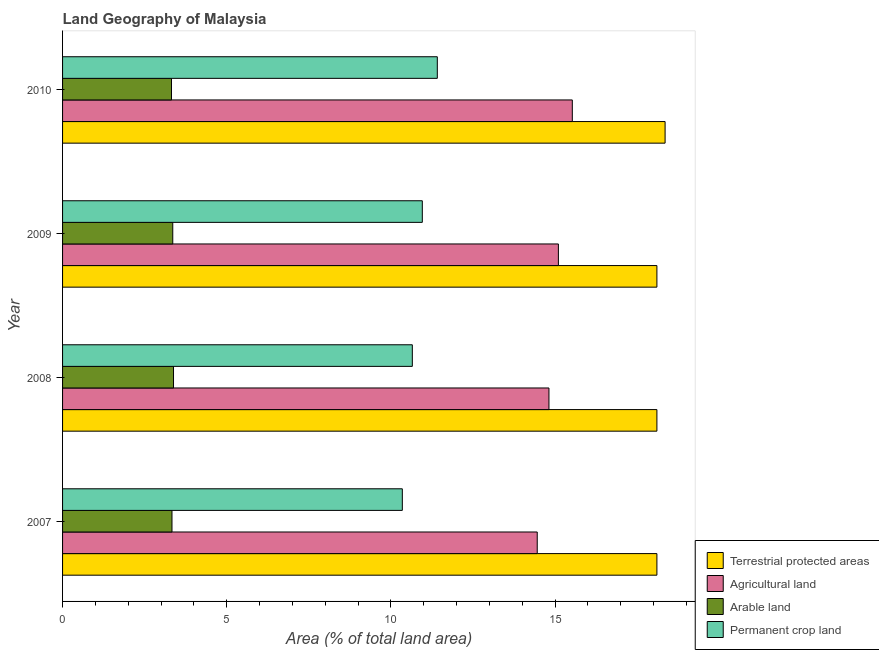Are the number of bars per tick equal to the number of legend labels?
Your answer should be compact. Yes. How many bars are there on the 2nd tick from the top?
Provide a short and direct response. 4. What is the label of the 4th group of bars from the top?
Provide a succinct answer. 2007. In how many cases, is the number of bars for a given year not equal to the number of legend labels?
Offer a terse response. 0. What is the percentage of area under permanent crop land in 2008?
Give a very brief answer. 10.65. Across all years, what is the maximum percentage of area under permanent crop land?
Offer a terse response. 11.41. Across all years, what is the minimum percentage of land under terrestrial protection?
Provide a short and direct response. 18.1. In which year was the percentage of area under arable land minimum?
Keep it short and to the point. 2010. What is the total percentage of area under permanent crop land in the graph?
Your answer should be compact. 43.37. What is the difference between the percentage of area under arable land in 2007 and that in 2008?
Offer a very short reply. -0.05. What is the difference between the percentage of area under agricultural land in 2010 and the percentage of area under permanent crop land in 2008?
Keep it short and to the point. 4.87. What is the average percentage of area under arable land per year?
Provide a short and direct response. 3.35. In the year 2008, what is the difference between the percentage of area under agricultural land and percentage of land under terrestrial protection?
Your answer should be very brief. -3.29. What is the ratio of the percentage of area under permanent crop land in 2008 to that in 2010?
Make the answer very short. 0.93. What is the difference between the highest and the second highest percentage of area under agricultural land?
Your response must be concise. 0.42. What is the difference between the highest and the lowest percentage of area under permanent crop land?
Provide a short and direct response. 1.07. In how many years, is the percentage of area under arable land greater than the average percentage of area under arable land taken over all years?
Your response must be concise. 2. Is the sum of the percentage of area under permanent crop land in 2008 and 2009 greater than the maximum percentage of area under agricultural land across all years?
Your answer should be very brief. Yes. What does the 4th bar from the top in 2009 represents?
Make the answer very short. Terrestrial protected areas. What does the 2nd bar from the bottom in 2007 represents?
Keep it short and to the point. Agricultural land. Are all the bars in the graph horizontal?
Provide a short and direct response. Yes. Does the graph contain any zero values?
Keep it short and to the point. No. Where does the legend appear in the graph?
Give a very brief answer. Bottom right. How are the legend labels stacked?
Your answer should be very brief. Vertical. What is the title of the graph?
Offer a terse response. Land Geography of Malaysia. Does "Korea" appear as one of the legend labels in the graph?
Your answer should be very brief. No. What is the label or title of the X-axis?
Provide a succinct answer. Area (% of total land area). What is the label or title of the Y-axis?
Your answer should be compact. Year. What is the Area (% of total land area) of Terrestrial protected areas in 2007?
Your answer should be compact. 18.1. What is the Area (% of total land area) in Agricultural land in 2007?
Make the answer very short. 14.46. What is the Area (% of total land area) in Arable land in 2007?
Provide a succinct answer. 3.33. What is the Area (% of total land area) in Permanent crop land in 2007?
Provide a succinct answer. 10.35. What is the Area (% of total land area) of Terrestrial protected areas in 2008?
Your response must be concise. 18.1. What is the Area (% of total land area) in Agricultural land in 2008?
Offer a terse response. 14.81. What is the Area (% of total land area) in Arable land in 2008?
Provide a succinct answer. 3.38. What is the Area (% of total land area) of Permanent crop land in 2008?
Your response must be concise. 10.65. What is the Area (% of total land area) in Terrestrial protected areas in 2009?
Your answer should be compact. 18.1. What is the Area (% of total land area) in Agricultural land in 2009?
Your answer should be compact. 15.1. What is the Area (% of total land area) of Arable land in 2009?
Make the answer very short. 3.36. What is the Area (% of total land area) in Permanent crop land in 2009?
Make the answer very short. 10.96. What is the Area (% of total land area) in Terrestrial protected areas in 2010?
Provide a succinct answer. 18.35. What is the Area (% of total land area) of Agricultural land in 2010?
Provide a short and direct response. 15.53. What is the Area (% of total land area) in Arable land in 2010?
Ensure brevity in your answer.  3.32. What is the Area (% of total land area) in Permanent crop land in 2010?
Offer a very short reply. 11.41. Across all years, what is the maximum Area (% of total land area) in Terrestrial protected areas?
Keep it short and to the point. 18.35. Across all years, what is the maximum Area (% of total land area) in Agricultural land?
Offer a very short reply. 15.53. Across all years, what is the maximum Area (% of total land area) in Arable land?
Your answer should be very brief. 3.38. Across all years, what is the maximum Area (% of total land area) in Permanent crop land?
Your response must be concise. 11.41. Across all years, what is the minimum Area (% of total land area) in Terrestrial protected areas?
Ensure brevity in your answer.  18.1. Across all years, what is the minimum Area (% of total land area) in Agricultural land?
Keep it short and to the point. 14.46. Across all years, what is the minimum Area (% of total land area) in Arable land?
Give a very brief answer. 3.32. Across all years, what is the minimum Area (% of total land area) in Permanent crop land?
Your answer should be compact. 10.35. What is the total Area (% of total land area) in Terrestrial protected areas in the graph?
Provide a succinct answer. 72.66. What is the total Area (% of total land area) in Agricultural land in the graph?
Ensure brevity in your answer.  59.9. What is the total Area (% of total land area) in Arable land in the graph?
Offer a terse response. 13.39. What is the total Area (% of total land area) of Permanent crop land in the graph?
Give a very brief answer. 43.37. What is the difference between the Area (% of total land area) in Terrestrial protected areas in 2007 and that in 2008?
Provide a short and direct response. 0. What is the difference between the Area (% of total land area) in Agricultural land in 2007 and that in 2008?
Ensure brevity in your answer.  -0.36. What is the difference between the Area (% of total land area) of Arable land in 2007 and that in 2008?
Make the answer very short. -0.05. What is the difference between the Area (% of total land area) in Permanent crop land in 2007 and that in 2008?
Provide a short and direct response. -0.3. What is the difference between the Area (% of total land area) of Terrestrial protected areas in 2007 and that in 2009?
Your answer should be compact. 0. What is the difference between the Area (% of total land area) of Agricultural land in 2007 and that in 2009?
Your answer should be compact. -0.64. What is the difference between the Area (% of total land area) in Arable land in 2007 and that in 2009?
Your response must be concise. -0.02. What is the difference between the Area (% of total land area) of Permanent crop land in 2007 and that in 2009?
Keep it short and to the point. -0.61. What is the difference between the Area (% of total land area) of Terrestrial protected areas in 2007 and that in 2010?
Keep it short and to the point. -0.25. What is the difference between the Area (% of total land area) of Agricultural land in 2007 and that in 2010?
Offer a terse response. -1.07. What is the difference between the Area (% of total land area) in Arable land in 2007 and that in 2010?
Offer a very short reply. 0.02. What is the difference between the Area (% of total land area) in Permanent crop land in 2007 and that in 2010?
Your answer should be very brief. -1.07. What is the difference between the Area (% of total land area) of Agricultural land in 2008 and that in 2009?
Offer a very short reply. -0.29. What is the difference between the Area (% of total land area) of Arable land in 2008 and that in 2009?
Make the answer very short. 0.02. What is the difference between the Area (% of total land area) of Permanent crop land in 2008 and that in 2009?
Your response must be concise. -0.3. What is the difference between the Area (% of total land area) of Terrestrial protected areas in 2008 and that in 2010?
Make the answer very short. -0.25. What is the difference between the Area (% of total land area) of Agricultural land in 2008 and that in 2010?
Your response must be concise. -0.71. What is the difference between the Area (% of total land area) in Arable land in 2008 and that in 2010?
Your answer should be compact. 0.06. What is the difference between the Area (% of total land area) of Permanent crop land in 2008 and that in 2010?
Your answer should be very brief. -0.76. What is the difference between the Area (% of total land area) of Terrestrial protected areas in 2009 and that in 2010?
Make the answer very short. -0.25. What is the difference between the Area (% of total land area) in Agricultural land in 2009 and that in 2010?
Offer a terse response. -0.42. What is the difference between the Area (% of total land area) of Arable land in 2009 and that in 2010?
Your response must be concise. 0.04. What is the difference between the Area (% of total land area) of Permanent crop land in 2009 and that in 2010?
Your response must be concise. -0.46. What is the difference between the Area (% of total land area) in Terrestrial protected areas in 2007 and the Area (% of total land area) in Agricultural land in 2008?
Ensure brevity in your answer.  3.29. What is the difference between the Area (% of total land area) in Terrestrial protected areas in 2007 and the Area (% of total land area) in Arable land in 2008?
Give a very brief answer. 14.72. What is the difference between the Area (% of total land area) in Terrestrial protected areas in 2007 and the Area (% of total land area) in Permanent crop land in 2008?
Ensure brevity in your answer.  7.45. What is the difference between the Area (% of total land area) in Agricultural land in 2007 and the Area (% of total land area) in Arable land in 2008?
Offer a terse response. 11.08. What is the difference between the Area (% of total land area) of Agricultural land in 2007 and the Area (% of total land area) of Permanent crop land in 2008?
Provide a short and direct response. 3.8. What is the difference between the Area (% of total land area) in Arable land in 2007 and the Area (% of total land area) in Permanent crop land in 2008?
Your answer should be compact. -7.32. What is the difference between the Area (% of total land area) in Terrestrial protected areas in 2007 and the Area (% of total land area) in Agricultural land in 2009?
Provide a succinct answer. 3. What is the difference between the Area (% of total land area) in Terrestrial protected areas in 2007 and the Area (% of total land area) in Arable land in 2009?
Your answer should be compact. 14.75. What is the difference between the Area (% of total land area) of Terrestrial protected areas in 2007 and the Area (% of total land area) of Permanent crop land in 2009?
Provide a succinct answer. 7.14. What is the difference between the Area (% of total land area) in Agricultural land in 2007 and the Area (% of total land area) in Arable land in 2009?
Make the answer very short. 11.1. What is the difference between the Area (% of total land area) in Agricultural land in 2007 and the Area (% of total land area) in Permanent crop land in 2009?
Make the answer very short. 3.5. What is the difference between the Area (% of total land area) in Arable land in 2007 and the Area (% of total land area) in Permanent crop land in 2009?
Give a very brief answer. -7.62. What is the difference between the Area (% of total land area) in Terrestrial protected areas in 2007 and the Area (% of total land area) in Agricultural land in 2010?
Keep it short and to the point. 2.58. What is the difference between the Area (% of total land area) of Terrestrial protected areas in 2007 and the Area (% of total land area) of Arable land in 2010?
Offer a very short reply. 14.78. What is the difference between the Area (% of total land area) in Terrestrial protected areas in 2007 and the Area (% of total land area) in Permanent crop land in 2010?
Give a very brief answer. 6.69. What is the difference between the Area (% of total land area) of Agricultural land in 2007 and the Area (% of total land area) of Arable land in 2010?
Your answer should be compact. 11.14. What is the difference between the Area (% of total land area) of Agricultural land in 2007 and the Area (% of total land area) of Permanent crop land in 2010?
Provide a short and direct response. 3.04. What is the difference between the Area (% of total land area) of Arable land in 2007 and the Area (% of total land area) of Permanent crop land in 2010?
Offer a very short reply. -8.08. What is the difference between the Area (% of total land area) of Terrestrial protected areas in 2008 and the Area (% of total land area) of Agricultural land in 2009?
Offer a very short reply. 3. What is the difference between the Area (% of total land area) in Terrestrial protected areas in 2008 and the Area (% of total land area) in Arable land in 2009?
Your response must be concise. 14.75. What is the difference between the Area (% of total land area) in Terrestrial protected areas in 2008 and the Area (% of total land area) in Permanent crop land in 2009?
Provide a succinct answer. 7.14. What is the difference between the Area (% of total land area) of Agricultural land in 2008 and the Area (% of total land area) of Arable land in 2009?
Make the answer very short. 11.46. What is the difference between the Area (% of total land area) of Agricultural land in 2008 and the Area (% of total land area) of Permanent crop land in 2009?
Your response must be concise. 3.86. What is the difference between the Area (% of total land area) of Arable land in 2008 and the Area (% of total land area) of Permanent crop land in 2009?
Offer a terse response. -7.58. What is the difference between the Area (% of total land area) of Terrestrial protected areas in 2008 and the Area (% of total land area) of Agricultural land in 2010?
Offer a terse response. 2.58. What is the difference between the Area (% of total land area) of Terrestrial protected areas in 2008 and the Area (% of total land area) of Arable land in 2010?
Your answer should be very brief. 14.78. What is the difference between the Area (% of total land area) of Terrestrial protected areas in 2008 and the Area (% of total land area) of Permanent crop land in 2010?
Provide a short and direct response. 6.69. What is the difference between the Area (% of total land area) in Agricultural land in 2008 and the Area (% of total land area) in Arable land in 2010?
Ensure brevity in your answer.  11.5. What is the difference between the Area (% of total land area) in Agricultural land in 2008 and the Area (% of total land area) in Permanent crop land in 2010?
Your answer should be very brief. 3.4. What is the difference between the Area (% of total land area) of Arable land in 2008 and the Area (% of total land area) of Permanent crop land in 2010?
Your response must be concise. -8.03. What is the difference between the Area (% of total land area) in Terrestrial protected areas in 2009 and the Area (% of total land area) in Agricultural land in 2010?
Keep it short and to the point. 2.58. What is the difference between the Area (% of total land area) of Terrestrial protected areas in 2009 and the Area (% of total land area) of Arable land in 2010?
Your answer should be very brief. 14.78. What is the difference between the Area (% of total land area) of Terrestrial protected areas in 2009 and the Area (% of total land area) of Permanent crop land in 2010?
Provide a short and direct response. 6.69. What is the difference between the Area (% of total land area) in Agricultural land in 2009 and the Area (% of total land area) in Arable land in 2010?
Make the answer very short. 11.78. What is the difference between the Area (% of total land area) of Agricultural land in 2009 and the Area (% of total land area) of Permanent crop land in 2010?
Ensure brevity in your answer.  3.69. What is the difference between the Area (% of total land area) in Arable land in 2009 and the Area (% of total land area) in Permanent crop land in 2010?
Ensure brevity in your answer.  -8.06. What is the average Area (% of total land area) in Terrestrial protected areas per year?
Ensure brevity in your answer.  18.16. What is the average Area (% of total land area) in Agricultural land per year?
Offer a terse response. 14.97. What is the average Area (% of total land area) of Arable land per year?
Your response must be concise. 3.35. What is the average Area (% of total land area) of Permanent crop land per year?
Offer a terse response. 10.84. In the year 2007, what is the difference between the Area (% of total land area) of Terrestrial protected areas and Area (% of total land area) of Agricultural land?
Keep it short and to the point. 3.64. In the year 2007, what is the difference between the Area (% of total land area) of Terrestrial protected areas and Area (% of total land area) of Arable land?
Ensure brevity in your answer.  14.77. In the year 2007, what is the difference between the Area (% of total land area) of Terrestrial protected areas and Area (% of total land area) of Permanent crop land?
Give a very brief answer. 7.75. In the year 2007, what is the difference between the Area (% of total land area) in Agricultural land and Area (% of total land area) in Arable land?
Ensure brevity in your answer.  11.12. In the year 2007, what is the difference between the Area (% of total land area) in Agricultural land and Area (% of total land area) in Permanent crop land?
Provide a short and direct response. 4.11. In the year 2007, what is the difference between the Area (% of total land area) of Arable land and Area (% of total land area) of Permanent crop land?
Make the answer very short. -7.02. In the year 2008, what is the difference between the Area (% of total land area) of Terrestrial protected areas and Area (% of total land area) of Agricultural land?
Offer a terse response. 3.29. In the year 2008, what is the difference between the Area (% of total land area) of Terrestrial protected areas and Area (% of total land area) of Arable land?
Your answer should be compact. 14.72. In the year 2008, what is the difference between the Area (% of total land area) in Terrestrial protected areas and Area (% of total land area) in Permanent crop land?
Your response must be concise. 7.45. In the year 2008, what is the difference between the Area (% of total land area) in Agricultural land and Area (% of total land area) in Arable land?
Your answer should be compact. 11.44. In the year 2008, what is the difference between the Area (% of total land area) of Agricultural land and Area (% of total land area) of Permanent crop land?
Make the answer very short. 4.16. In the year 2008, what is the difference between the Area (% of total land area) of Arable land and Area (% of total land area) of Permanent crop land?
Offer a terse response. -7.27. In the year 2009, what is the difference between the Area (% of total land area) in Terrestrial protected areas and Area (% of total land area) in Agricultural land?
Keep it short and to the point. 3. In the year 2009, what is the difference between the Area (% of total land area) of Terrestrial protected areas and Area (% of total land area) of Arable land?
Ensure brevity in your answer.  14.75. In the year 2009, what is the difference between the Area (% of total land area) of Terrestrial protected areas and Area (% of total land area) of Permanent crop land?
Provide a short and direct response. 7.14. In the year 2009, what is the difference between the Area (% of total land area) in Agricultural land and Area (% of total land area) in Arable land?
Your response must be concise. 11.75. In the year 2009, what is the difference between the Area (% of total land area) of Agricultural land and Area (% of total land area) of Permanent crop land?
Offer a terse response. 4.14. In the year 2009, what is the difference between the Area (% of total land area) in Arable land and Area (% of total land area) in Permanent crop land?
Offer a terse response. -7.6. In the year 2010, what is the difference between the Area (% of total land area) in Terrestrial protected areas and Area (% of total land area) in Agricultural land?
Offer a terse response. 2.83. In the year 2010, what is the difference between the Area (% of total land area) of Terrestrial protected areas and Area (% of total land area) of Arable land?
Offer a very short reply. 15.03. In the year 2010, what is the difference between the Area (% of total land area) of Terrestrial protected areas and Area (% of total land area) of Permanent crop land?
Make the answer very short. 6.94. In the year 2010, what is the difference between the Area (% of total land area) of Agricultural land and Area (% of total land area) of Arable land?
Offer a very short reply. 12.21. In the year 2010, what is the difference between the Area (% of total land area) of Agricultural land and Area (% of total land area) of Permanent crop land?
Keep it short and to the point. 4.11. In the year 2010, what is the difference between the Area (% of total land area) in Arable land and Area (% of total land area) in Permanent crop land?
Your response must be concise. -8.1. What is the ratio of the Area (% of total land area) of Agricultural land in 2007 to that in 2008?
Your answer should be very brief. 0.98. What is the ratio of the Area (% of total land area) of Arable land in 2007 to that in 2008?
Provide a succinct answer. 0.99. What is the ratio of the Area (% of total land area) of Permanent crop land in 2007 to that in 2008?
Provide a succinct answer. 0.97. What is the ratio of the Area (% of total land area) in Agricultural land in 2007 to that in 2009?
Your answer should be compact. 0.96. What is the ratio of the Area (% of total land area) of Terrestrial protected areas in 2007 to that in 2010?
Keep it short and to the point. 0.99. What is the ratio of the Area (% of total land area) of Agricultural land in 2007 to that in 2010?
Offer a very short reply. 0.93. What is the ratio of the Area (% of total land area) in Permanent crop land in 2007 to that in 2010?
Your answer should be very brief. 0.91. What is the ratio of the Area (% of total land area) of Terrestrial protected areas in 2008 to that in 2009?
Give a very brief answer. 1. What is the ratio of the Area (% of total land area) of Agricultural land in 2008 to that in 2009?
Offer a terse response. 0.98. What is the ratio of the Area (% of total land area) in Permanent crop land in 2008 to that in 2009?
Provide a short and direct response. 0.97. What is the ratio of the Area (% of total land area) of Terrestrial protected areas in 2008 to that in 2010?
Provide a short and direct response. 0.99. What is the ratio of the Area (% of total land area) of Agricultural land in 2008 to that in 2010?
Ensure brevity in your answer.  0.95. What is the ratio of the Area (% of total land area) in Arable land in 2008 to that in 2010?
Your answer should be very brief. 1.02. What is the ratio of the Area (% of total land area) in Permanent crop land in 2008 to that in 2010?
Provide a succinct answer. 0.93. What is the ratio of the Area (% of total land area) in Terrestrial protected areas in 2009 to that in 2010?
Make the answer very short. 0.99. What is the ratio of the Area (% of total land area) in Agricultural land in 2009 to that in 2010?
Give a very brief answer. 0.97. What is the ratio of the Area (% of total land area) of Arable land in 2009 to that in 2010?
Your answer should be very brief. 1.01. What is the ratio of the Area (% of total land area) of Permanent crop land in 2009 to that in 2010?
Provide a succinct answer. 0.96. What is the difference between the highest and the second highest Area (% of total land area) in Terrestrial protected areas?
Provide a succinct answer. 0.25. What is the difference between the highest and the second highest Area (% of total land area) in Agricultural land?
Your response must be concise. 0.42. What is the difference between the highest and the second highest Area (% of total land area) of Arable land?
Offer a terse response. 0.02. What is the difference between the highest and the second highest Area (% of total land area) of Permanent crop land?
Offer a very short reply. 0.46. What is the difference between the highest and the lowest Area (% of total land area) of Terrestrial protected areas?
Make the answer very short. 0.25. What is the difference between the highest and the lowest Area (% of total land area) in Agricultural land?
Ensure brevity in your answer.  1.07. What is the difference between the highest and the lowest Area (% of total land area) in Arable land?
Your answer should be very brief. 0.06. What is the difference between the highest and the lowest Area (% of total land area) in Permanent crop land?
Offer a very short reply. 1.07. 